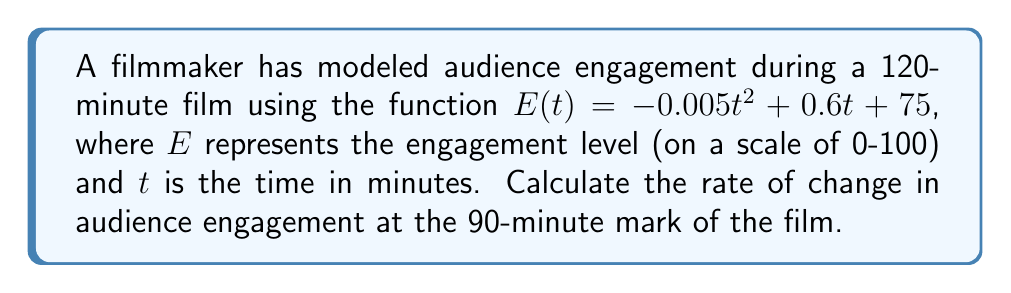Give your solution to this math problem. To find the rate of change in audience engagement at a specific point, we need to calculate the derivative of the given function and evaluate it at the desired time.

Step 1: Determine the function for audience engagement.
$E(t) = -0.005t^2 + 0.6t + 75$

Step 2: Calculate the derivative of $E(t)$ with respect to $t$.
$$\frac{dE}{dt} = \frac{d}{dt}(-0.005t^2 + 0.6t + 75)$$
$$\frac{dE}{dt} = -0.01t + 0.6$$

Step 3: Evaluate the derivative at $t = 90$ minutes.
$$\frac{dE}{dt}\bigg|_{t=90} = -0.01(90) + 0.6$$
$$\frac{dE}{dt}\bigg|_{t=90} = -0.9 + 0.6 = -0.3$$

The negative value indicates that the audience engagement is decreasing at this point in the film.
Answer: $-0.3$ engagement units per minute 